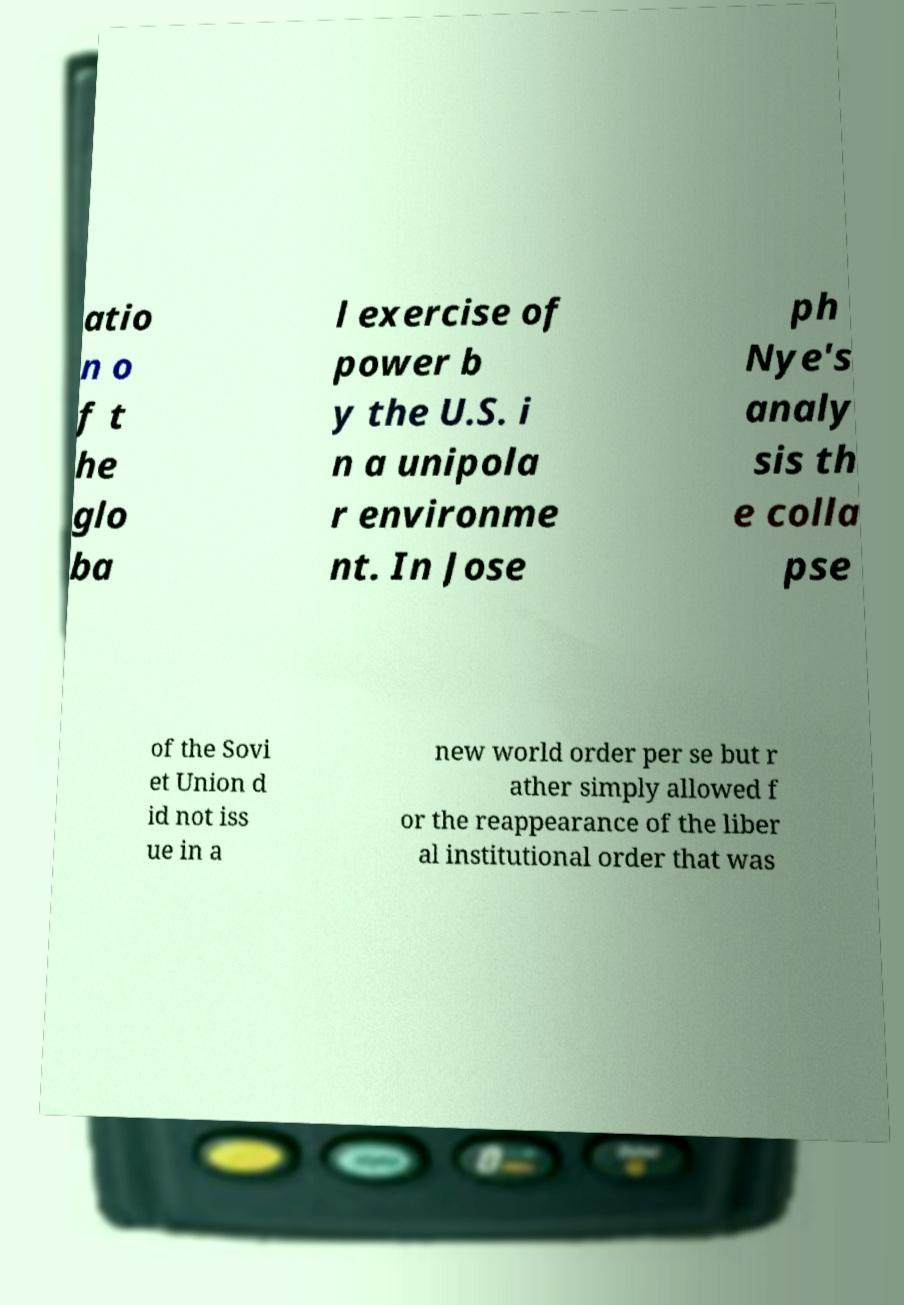Can you read and provide the text displayed in the image?This photo seems to have some interesting text. Can you extract and type it out for me? atio n o f t he glo ba l exercise of power b y the U.S. i n a unipola r environme nt. In Jose ph Nye's analy sis th e colla pse of the Sovi et Union d id not iss ue in a new world order per se but r ather simply allowed f or the reappearance of the liber al institutional order that was 